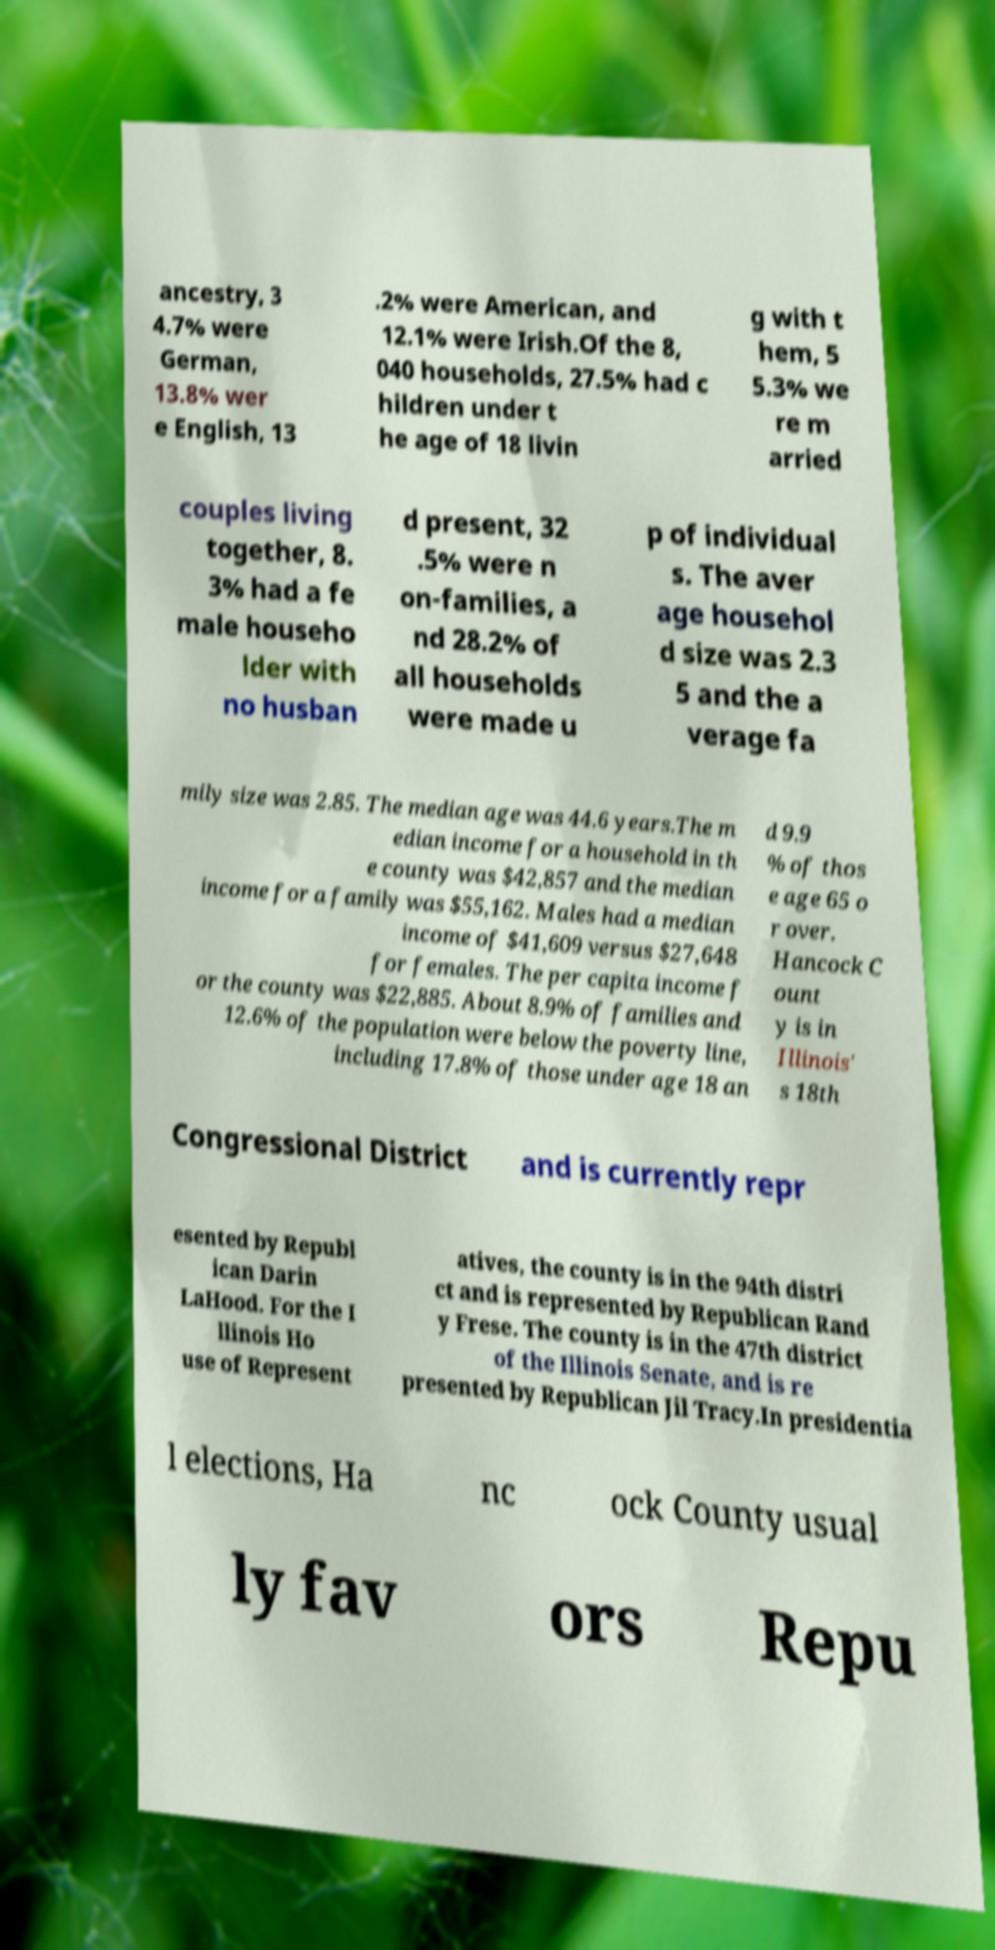Can you accurately transcribe the text from the provided image for me? ancestry, 3 4.7% were German, 13.8% wer e English, 13 .2% were American, and 12.1% were Irish.Of the 8, 040 households, 27.5% had c hildren under t he age of 18 livin g with t hem, 5 5.3% we re m arried couples living together, 8. 3% had a fe male househo lder with no husban d present, 32 .5% were n on-families, a nd 28.2% of all households were made u p of individual s. The aver age househol d size was 2.3 5 and the a verage fa mily size was 2.85. The median age was 44.6 years.The m edian income for a household in th e county was $42,857 and the median income for a family was $55,162. Males had a median income of $41,609 versus $27,648 for females. The per capita income f or the county was $22,885. About 8.9% of families and 12.6% of the population were below the poverty line, including 17.8% of those under age 18 an d 9.9 % of thos e age 65 o r over. Hancock C ount y is in Illinois' s 18th Congressional District and is currently repr esented by Republ ican Darin LaHood. For the I llinois Ho use of Represent atives, the county is in the 94th distri ct and is represented by Republican Rand y Frese. The county is in the 47th district of the Illinois Senate, and is re presented by Republican Jil Tracy.In presidentia l elections, Ha nc ock County usual ly fav ors Repu 